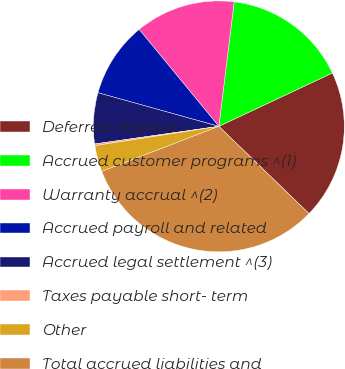<chart> <loc_0><loc_0><loc_500><loc_500><pie_chart><fcel>Deferred revenue<fcel>Accrued customer programs ^(1)<fcel>Warranty accrual ^(2)<fcel>Accrued payroll and related<fcel>Accrued legal settlement ^(3)<fcel>Taxes payable short- term<fcel>Other<fcel>Total accrued liabilities and<nl><fcel>19.23%<fcel>16.06%<fcel>12.9%<fcel>9.73%<fcel>6.56%<fcel>0.22%<fcel>3.39%<fcel>31.91%<nl></chart> 